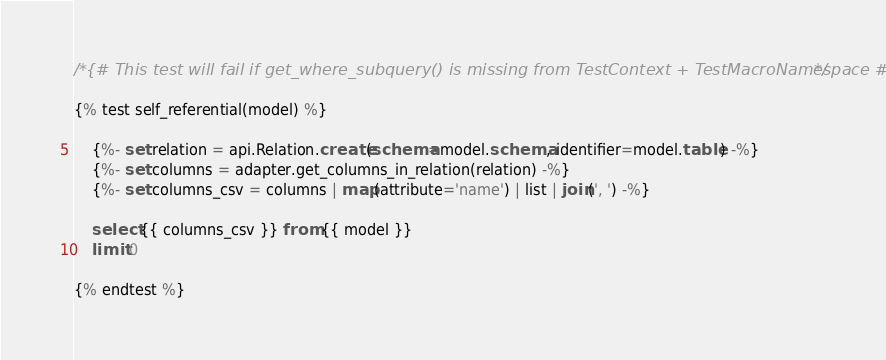Convert code to text. <code><loc_0><loc_0><loc_500><loc_500><_SQL_>/*{# This test will fail if get_where_subquery() is missing from TestContext + TestMacroNamespace #}*/

{% test self_referential(model) %}

    {%- set relation = api.Relation.create(schema=model.schema, identifier=model.table) -%}
    {%- set columns = adapter.get_columns_in_relation(relation) -%}
    {%- set columns_csv = columns | map(attribute='name') | list | join(', ') -%}

    select {{ columns_csv }} from {{ model }}
    limit 0

{% endtest %}
</code> 